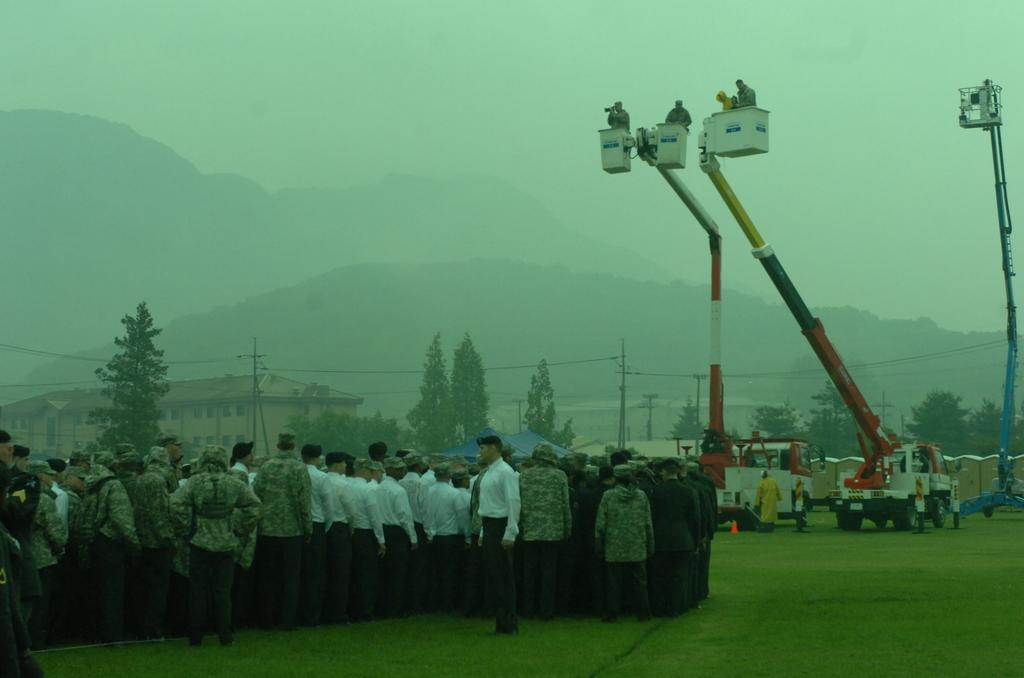What can be seen on the left side of the image? There is a group of people standing on the left side of the image. What else is present in the image besides the group of people? There are two vehicles in the image. What are the vehicles doing in the image? The vehicles are lifting people. What is visible at the top of the image? The sky is visible at the top of the image. How would you describe the sky in the image? The sky appears to be foggy. What type of fork can be seen in the image? There is no fork present in the image. What shape is the square in the image? There is no square present in the image. 